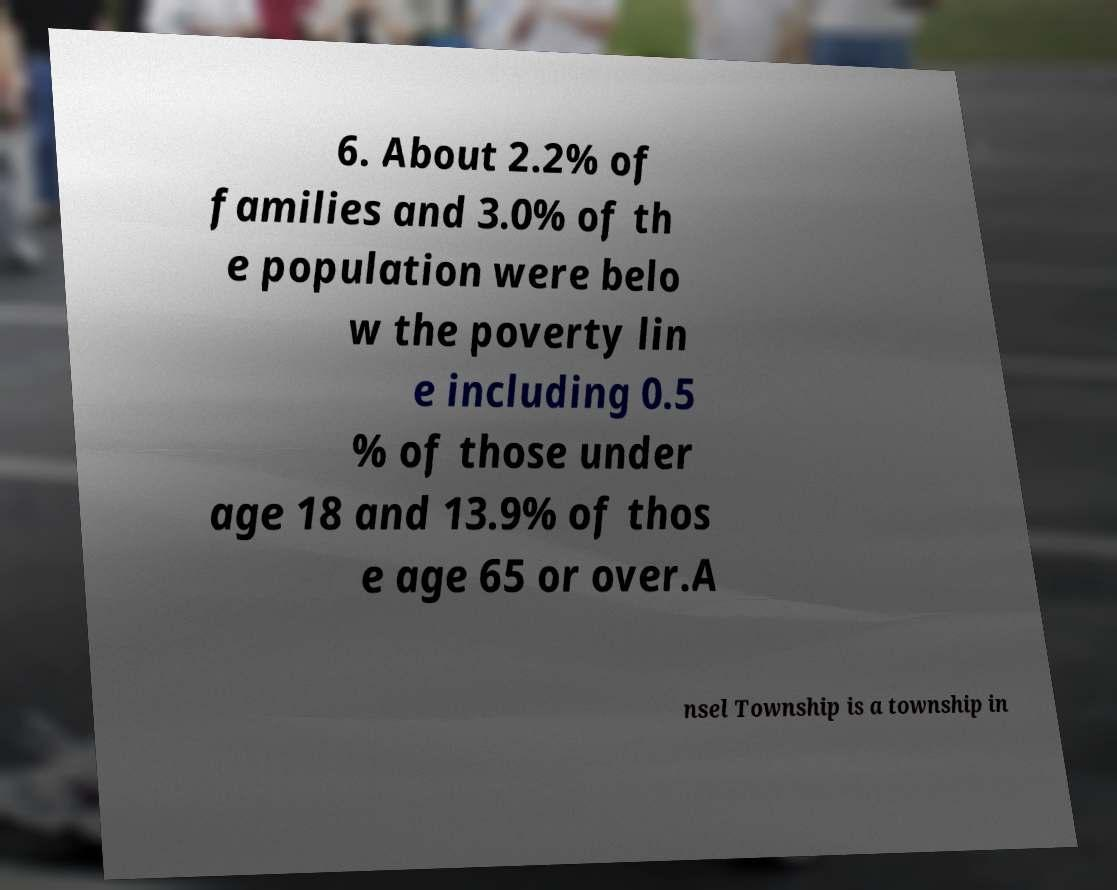Can you accurately transcribe the text from the provided image for me? 6. About 2.2% of families and 3.0% of th e population were belo w the poverty lin e including 0.5 % of those under age 18 and 13.9% of thos e age 65 or over.A nsel Township is a township in 